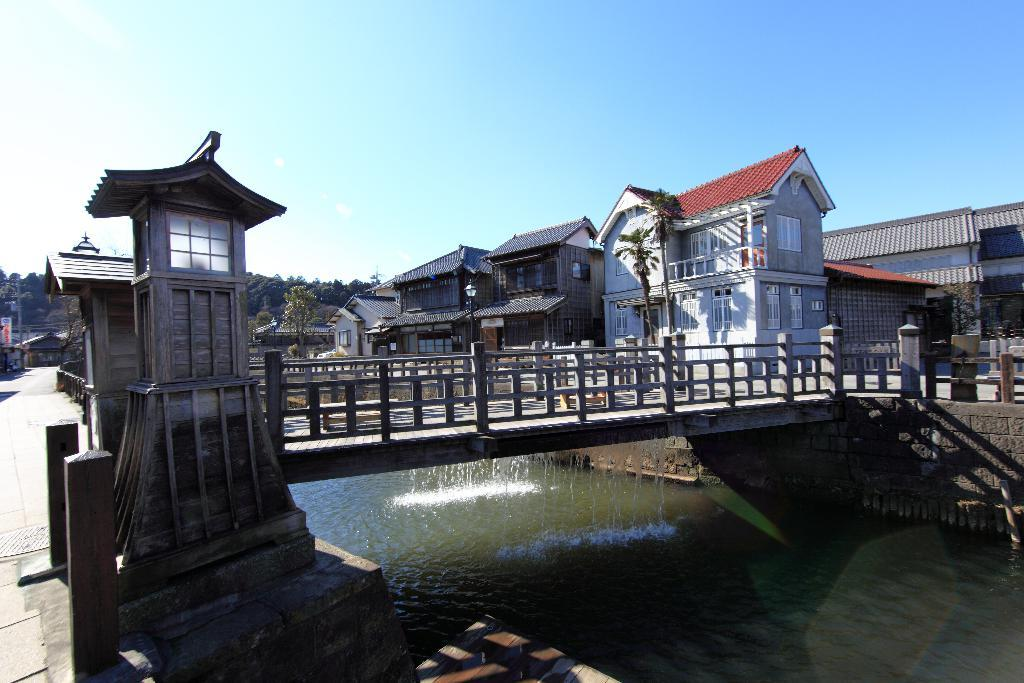What type of structure is present in the image? There is a bridge in the image. What else can be seen in the image besides the bridge? There are buildings, trees, electric poles, and a banner in the image. What is visible under the bridge? Water is visible under the bridge. What is visible in the background of the image? The sky is visible in the background of the image. What type of farm animals can be seen grazing on the grass in the image? There are no farm animals present in the image. Which famous actor can be seen walking across the bridge in the image? There are no actors present in the image, as it is a photograph of a real-life location. 